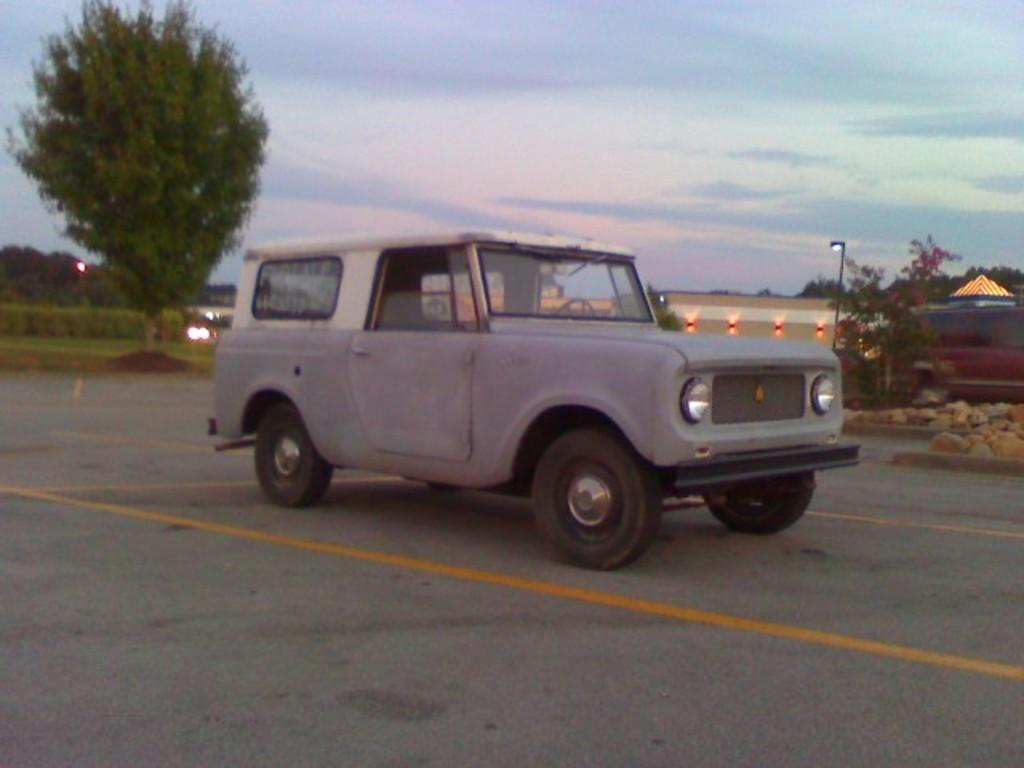What types of vehicles are in the image? There are vehicles in the image, but the specific types are not mentioned. What is the primary surface visible in the image? There is a road in the image. What natural elements can be seen in the image? There are rocks, trees, and grass in the image. What man-made structure is present in the image? There is a light pole in the image. What type of lighting is present in the image? There are lights in the image. How would you describe the sky in the image? The sky is cloudy in the image. What type of bun is being used to form the road in the image? There is no bun present in the image, and the road is not made of any bun. How does the tax system work for the vehicles in the image? There is no information about a tax system for the vehicles in the image. 